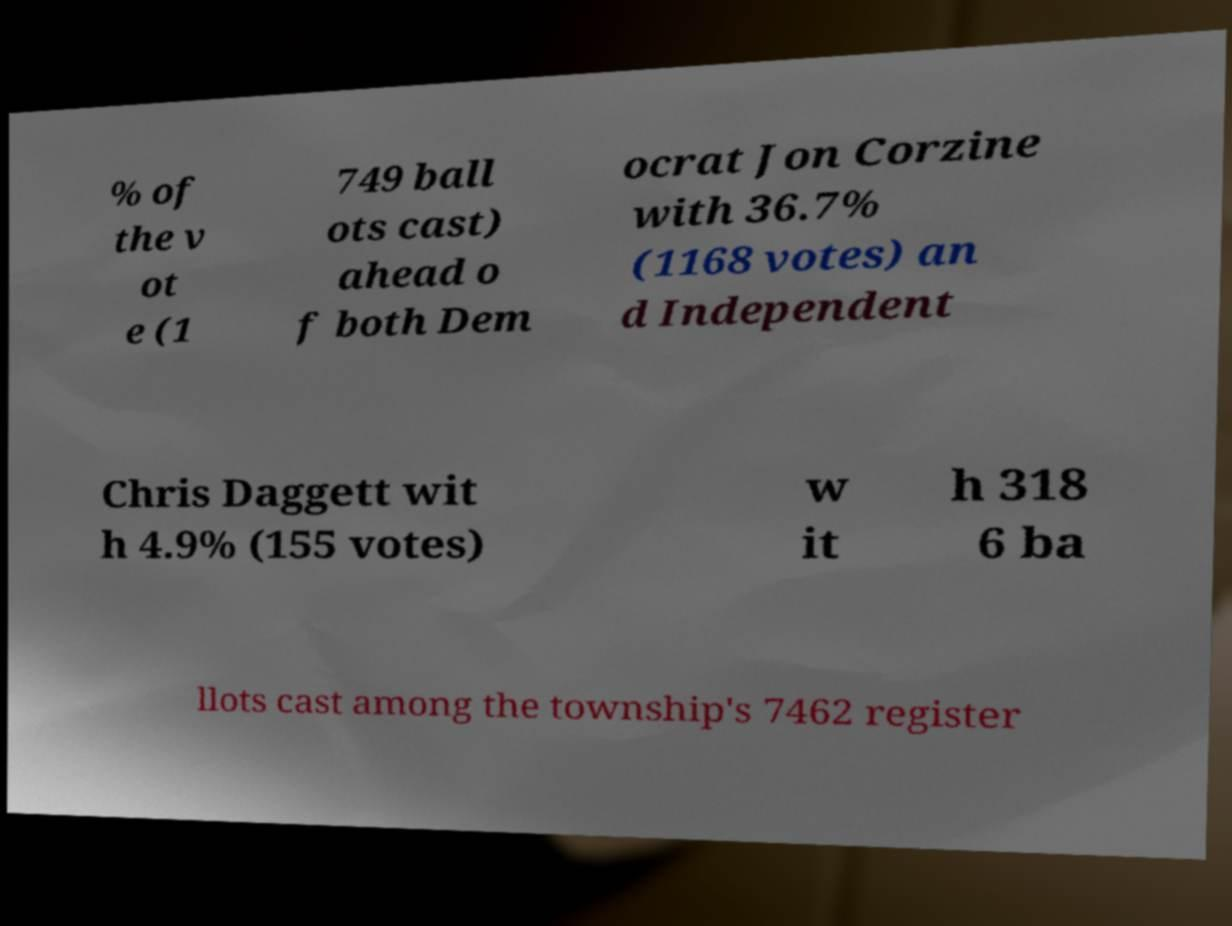For documentation purposes, I need the text within this image transcribed. Could you provide that? % of the v ot e (1 749 ball ots cast) ahead o f both Dem ocrat Jon Corzine with 36.7% (1168 votes) an d Independent Chris Daggett wit h 4.9% (155 votes) w it h 318 6 ba llots cast among the township's 7462 register 